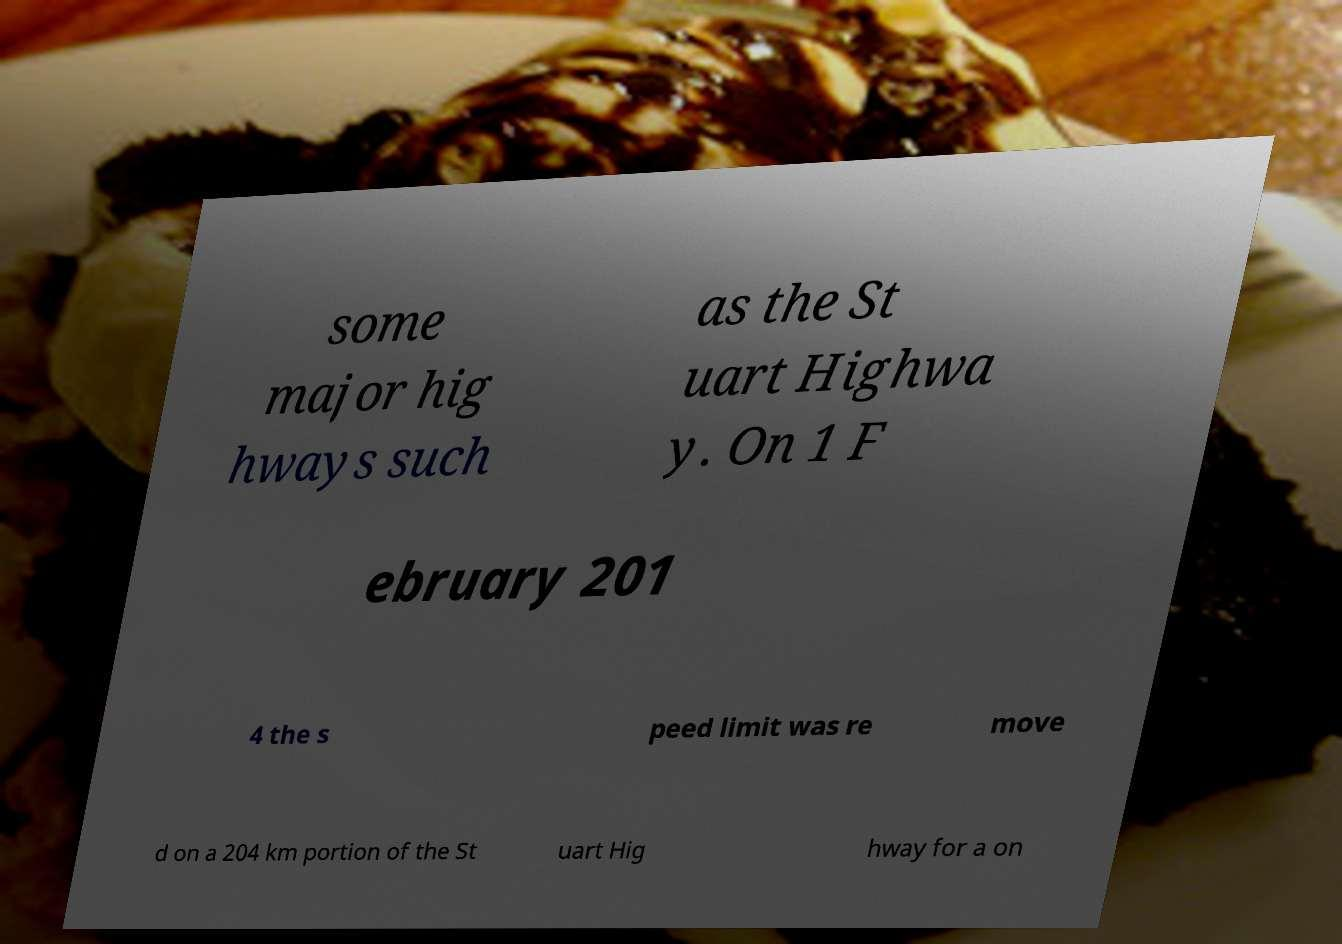I need the written content from this picture converted into text. Can you do that? some major hig hways such as the St uart Highwa y. On 1 F ebruary 201 4 the s peed limit was re move d on a 204 km portion of the St uart Hig hway for a on 